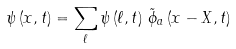Convert formula to latex. <formula><loc_0><loc_0><loc_500><loc_500>\psi \left ( x , t \right ) = \sum _ { \ell } \psi \left ( \ell , t \right ) \, \tilde { \phi } _ { a } \left ( x - X , t \right )</formula> 